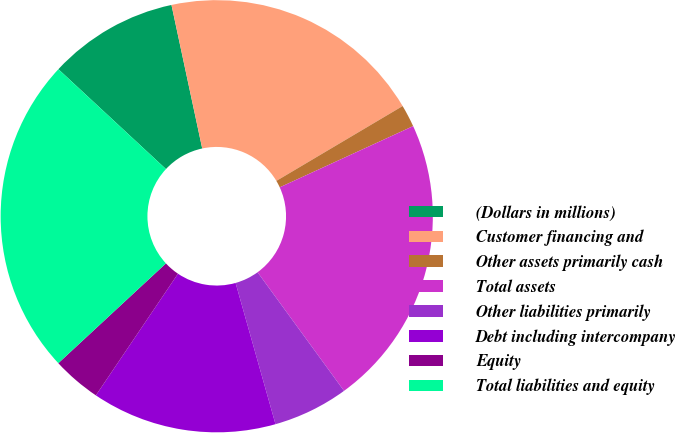<chart> <loc_0><loc_0><loc_500><loc_500><pie_chart><fcel>(Dollars in millions)<fcel>Customer financing and<fcel>Other assets primarily cash<fcel>Total assets<fcel>Other liabilities primarily<fcel>Debt including intercompany<fcel>Equity<fcel>Total liabilities and equity<nl><fcel>9.73%<fcel>19.84%<fcel>1.67%<fcel>21.82%<fcel>5.64%<fcel>13.83%<fcel>3.65%<fcel>23.81%<nl></chart> 